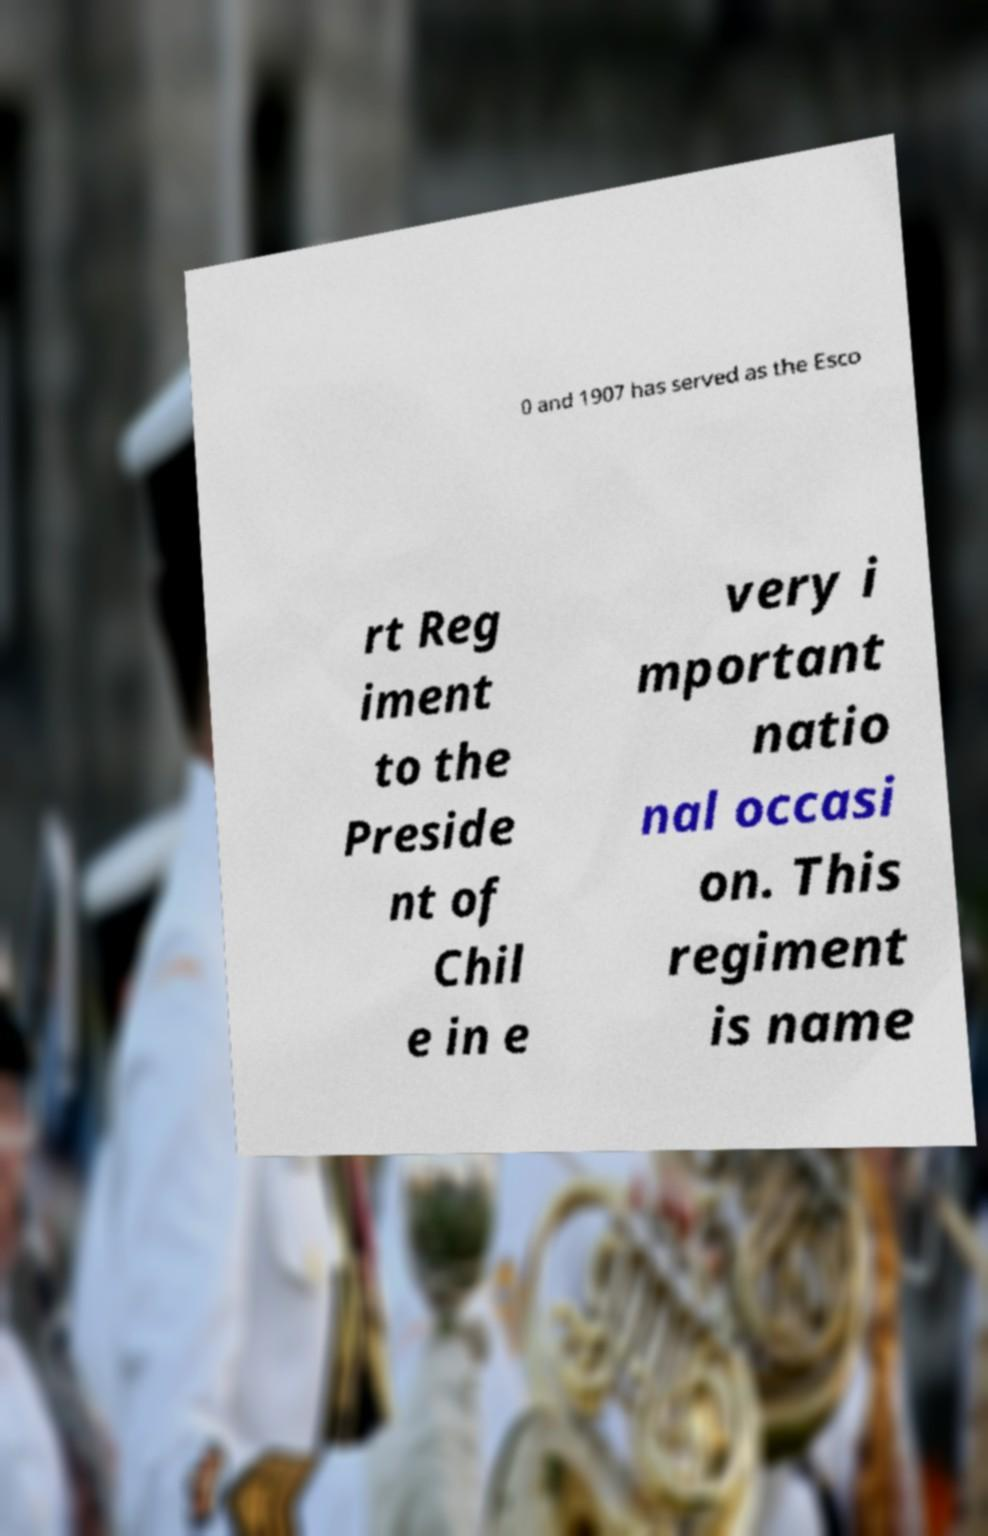Can you read and provide the text displayed in the image?This photo seems to have some interesting text. Can you extract and type it out for me? 0 and 1907 has served as the Esco rt Reg iment to the Preside nt of Chil e in e very i mportant natio nal occasi on. This regiment is name 